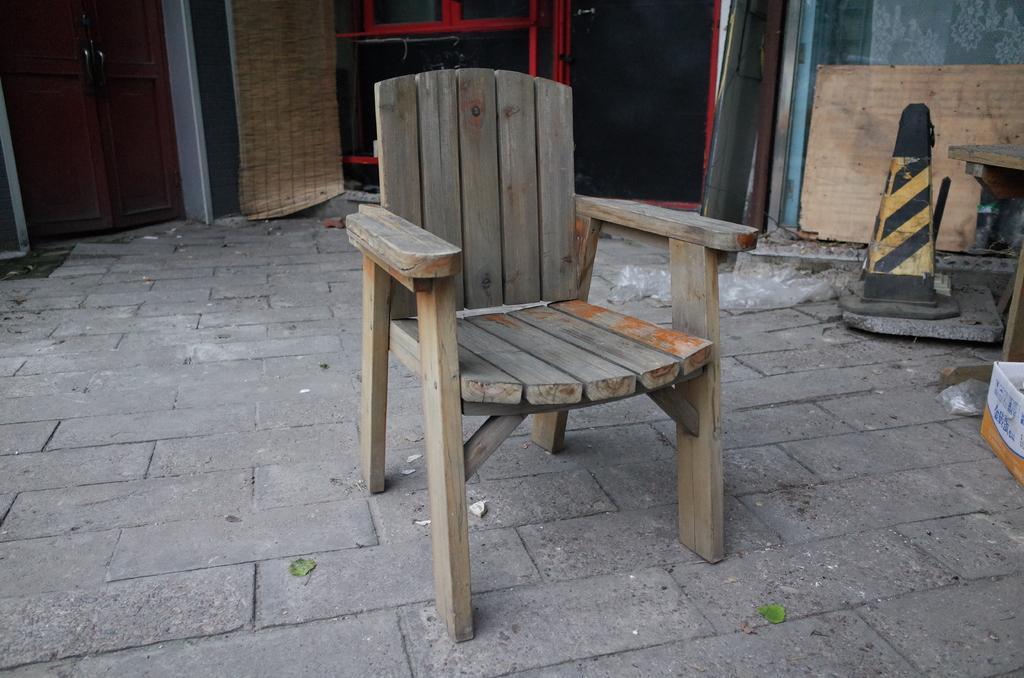How would you summarize this image in a sentence or two? In this image we can see a wooden chair. On the right side there is a traffic cone, box and many other items. In the back there are doors. 